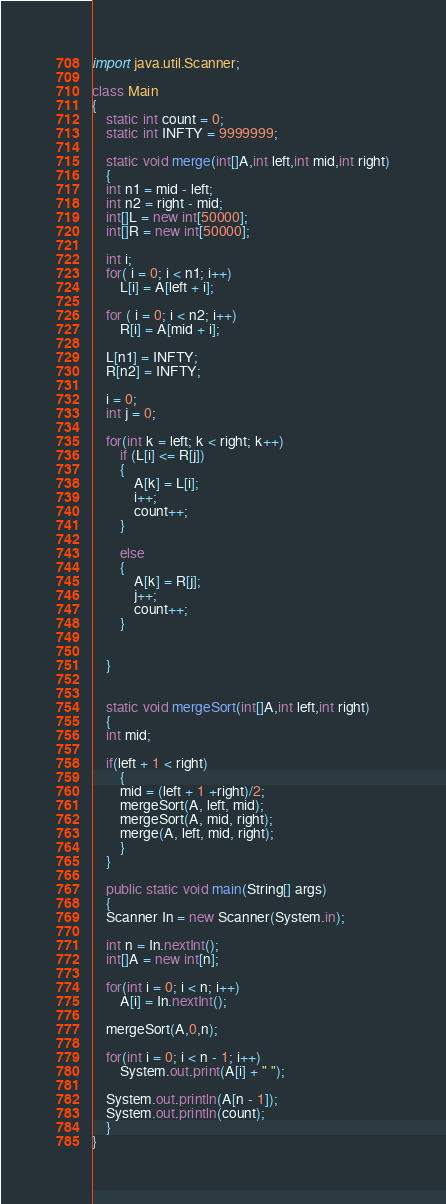<code> <loc_0><loc_0><loc_500><loc_500><_Java_>import java.util.Scanner;

class Main
{
    static int count = 0;
    static int INFTY = 9999999;

    static void merge(int[]A,int left,int mid,int right)
    {
	int n1 = mid - left;
	int n2 = right - mid;
	int[]L = new int[50000];
	int[]R = new int[50000];

	int i;
	for( i = 0; i < n1; i++) 
	    L[i] = A[left + i];

	for ( i = 0; i < n2; i++)
	    R[i] = A[mid + i];

	L[n1] = INFTY;
	R[n2] = INFTY;
	
	i = 0;
	int j = 0;
	
	for(int k = left; k < right; k++)
	    if (L[i] <= R[j])
		{
		    A[k] = L[i];
		    i++;
		    count++;
		}

	    else 
		{
		    A[k] = R[j];
		    j++;
		    count++;
		}
     

    }
        
	
    static void mergeSort(int[]A,int left,int right)
    {
	int mid;

	if(left + 1 < right)
	    {
		mid = (left + 1 +right)/2;
		mergeSort(A, left, mid);
		mergeSort(A, mid, right);
		merge(A, left, mid, right);
	    }
    }

    public static void main(String[] args)
    {
	Scanner In = new Scanner(System.in);

	int n = In.nextInt();
	int[]A = new int[n];

	for(int i = 0; i < n; i++)
	    A[i] = In.nextInt();

	mergeSort(A,0,n);

	for(int i = 0; i < n - 1; i++)
	    System.out.print(A[i] + " ");

	System.out.println(A[n - 1]);
	System.out.println(count);
    }
}</code> 